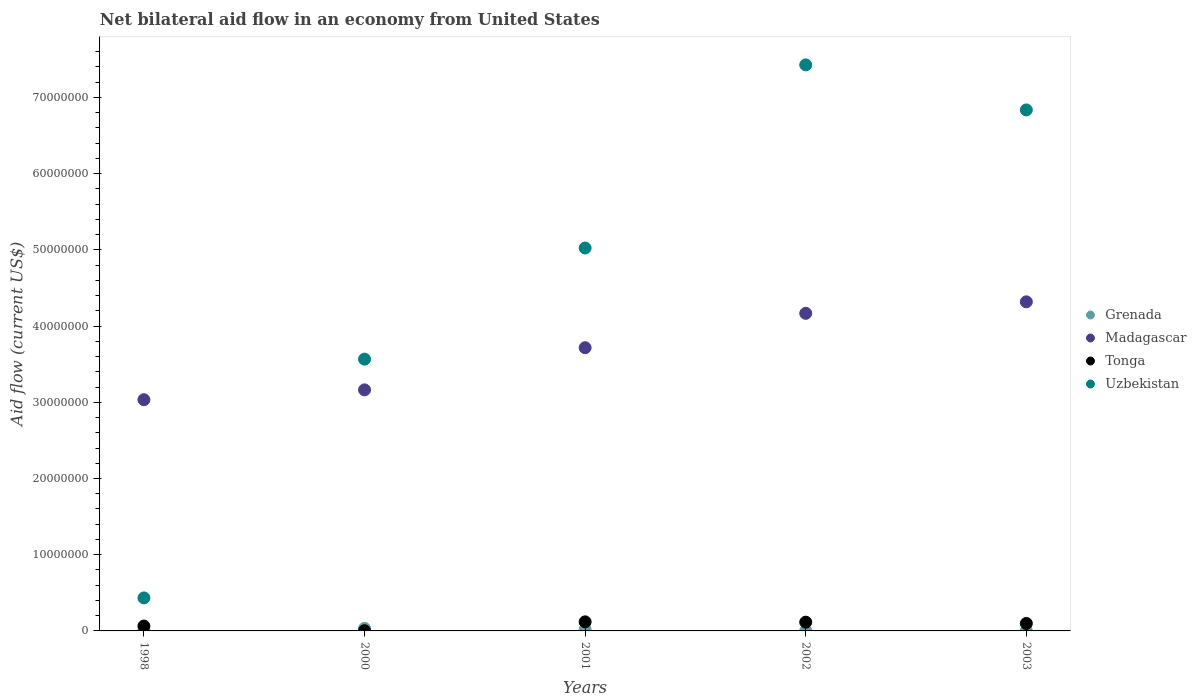How many different coloured dotlines are there?
Provide a succinct answer. 4. What is the net bilateral aid flow in Tonga in 2002?
Offer a very short reply. 1.15e+06. Across all years, what is the maximum net bilateral aid flow in Uzbekistan?
Make the answer very short. 7.43e+07. Across all years, what is the minimum net bilateral aid flow in Uzbekistan?
Your answer should be very brief. 4.33e+06. In which year was the net bilateral aid flow in Uzbekistan minimum?
Your response must be concise. 1998. What is the total net bilateral aid flow in Madagascar in the graph?
Ensure brevity in your answer.  1.84e+08. What is the difference between the net bilateral aid flow in Tonga in 2001 and that in 2002?
Ensure brevity in your answer.  4.00e+04. What is the difference between the net bilateral aid flow in Uzbekistan in 2002 and the net bilateral aid flow in Madagascar in 2001?
Give a very brief answer. 3.71e+07. What is the average net bilateral aid flow in Madagascar per year?
Your response must be concise. 3.68e+07. In the year 1998, what is the difference between the net bilateral aid flow in Tonga and net bilateral aid flow in Madagascar?
Provide a short and direct response. -2.97e+07. In how many years, is the net bilateral aid flow in Uzbekistan greater than 42000000 US$?
Offer a terse response. 3. What is the ratio of the net bilateral aid flow in Tonga in 1998 to that in 2002?
Give a very brief answer. 0.56. Is the net bilateral aid flow in Tonga in 2000 less than that in 2003?
Your answer should be very brief. Yes. Is the difference between the net bilateral aid flow in Tonga in 2002 and 2003 greater than the difference between the net bilateral aid flow in Madagascar in 2002 and 2003?
Offer a terse response. Yes. What is the difference between the highest and the second highest net bilateral aid flow in Madagascar?
Provide a succinct answer. 1.51e+06. What is the difference between the highest and the lowest net bilateral aid flow in Madagascar?
Offer a terse response. 1.28e+07. Is the sum of the net bilateral aid flow in Uzbekistan in 2001 and 2003 greater than the maximum net bilateral aid flow in Tonga across all years?
Give a very brief answer. Yes. Is it the case that in every year, the sum of the net bilateral aid flow in Tonga and net bilateral aid flow in Grenada  is greater than the sum of net bilateral aid flow in Uzbekistan and net bilateral aid flow in Madagascar?
Make the answer very short. No. Does the net bilateral aid flow in Uzbekistan monotonically increase over the years?
Your response must be concise. No. Is the net bilateral aid flow in Grenada strictly less than the net bilateral aid flow in Madagascar over the years?
Keep it short and to the point. Yes. What is the difference between two consecutive major ticks on the Y-axis?
Ensure brevity in your answer.  1.00e+07. Are the values on the major ticks of Y-axis written in scientific E-notation?
Make the answer very short. No. Does the graph contain any zero values?
Provide a short and direct response. No. Does the graph contain grids?
Provide a succinct answer. No. How many legend labels are there?
Offer a very short reply. 4. What is the title of the graph?
Your answer should be very brief. Net bilateral aid flow in an economy from United States. What is the Aid flow (current US$) in Madagascar in 1998?
Make the answer very short. 3.03e+07. What is the Aid flow (current US$) of Tonga in 1998?
Make the answer very short. 6.40e+05. What is the Aid flow (current US$) in Uzbekistan in 1998?
Provide a succinct answer. 4.33e+06. What is the Aid flow (current US$) in Madagascar in 2000?
Offer a terse response. 3.16e+07. What is the Aid flow (current US$) of Tonga in 2000?
Make the answer very short. 3.00e+04. What is the Aid flow (current US$) in Uzbekistan in 2000?
Ensure brevity in your answer.  3.57e+07. What is the Aid flow (current US$) in Madagascar in 2001?
Provide a short and direct response. 3.72e+07. What is the Aid flow (current US$) in Tonga in 2001?
Make the answer very short. 1.19e+06. What is the Aid flow (current US$) in Uzbekistan in 2001?
Offer a very short reply. 5.02e+07. What is the Aid flow (current US$) of Grenada in 2002?
Provide a succinct answer. 2.00e+04. What is the Aid flow (current US$) of Madagascar in 2002?
Make the answer very short. 4.17e+07. What is the Aid flow (current US$) in Tonga in 2002?
Offer a very short reply. 1.15e+06. What is the Aid flow (current US$) of Uzbekistan in 2002?
Make the answer very short. 7.43e+07. What is the Aid flow (current US$) in Madagascar in 2003?
Provide a succinct answer. 4.32e+07. What is the Aid flow (current US$) of Tonga in 2003?
Ensure brevity in your answer.  9.80e+05. What is the Aid flow (current US$) of Uzbekistan in 2003?
Your answer should be very brief. 6.84e+07. Across all years, what is the maximum Aid flow (current US$) of Grenada?
Provide a succinct answer. 3.40e+05. Across all years, what is the maximum Aid flow (current US$) of Madagascar?
Provide a short and direct response. 4.32e+07. Across all years, what is the maximum Aid flow (current US$) in Tonga?
Ensure brevity in your answer.  1.19e+06. Across all years, what is the maximum Aid flow (current US$) of Uzbekistan?
Provide a succinct answer. 7.43e+07. Across all years, what is the minimum Aid flow (current US$) of Grenada?
Offer a terse response. 10000. Across all years, what is the minimum Aid flow (current US$) of Madagascar?
Keep it short and to the point. 3.03e+07. Across all years, what is the minimum Aid flow (current US$) of Tonga?
Your answer should be very brief. 3.00e+04. Across all years, what is the minimum Aid flow (current US$) of Uzbekistan?
Provide a short and direct response. 4.33e+06. What is the total Aid flow (current US$) of Madagascar in the graph?
Your answer should be compact. 1.84e+08. What is the total Aid flow (current US$) in Tonga in the graph?
Give a very brief answer. 3.99e+06. What is the total Aid flow (current US$) of Uzbekistan in the graph?
Your answer should be compact. 2.33e+08. What is the difference between the Aid flow (current US$) of Madagascar in 1998 and that in 2000?
Offer a very short reply. -1.29e+06. What is the difference between the Aid flow (current US$) of Uzbekistan in 1998 and that in 2000?
Ensure brevity in your answer.  -3.13e+07. What is the difference between the Aid flow (current US$) of Grenada in 1998 and that in 2001?
Your answer should be very brief. -5.00e+04. What is the difference between the Aid flow (current US$) of Madagascar in 1998 and that in 2001?
Provide a short and direct response. -6.82e+06. What is the difference between the Aid flow (current US$) of Tonga in 1998 and that in 2001?
Make the answer very short. -5.50e+05. What is the difference between the Aid flow (current US$) of Uzbekistan in 1998 and that in 2001?
Offer a very short reply. -4.59e+07. What is the difference between the Aid flow (current US$) of Madagascar in 1998 and that in 2002?
Your response must be concise. -1.13e+07. What is the difference between the Aid flow (current US$) of Tonga in 1998 and that in 2002?
Ensure brevity in your answer.  -5.10e+05. What is the difference between the Aid flow (current US$) of Uzbekistan in 1998 and that in 2002?
Offer a very short reply. -6.99e+07. What is the difference between the Aid flow (current US$) of Madagascar in 1998 and that in 2003?
Offer a terse response. -1.28e+07. What is the difference between the Aid flow (current US$) of Uzbekistan in 1998 and that in 2003?
Your response must be concise. -6.40e+07. What is the difference between the Aid flow (current US$) of Madagascar in 2000 and that in 2001?
Give a very brief answer. -5.53e+06. What is the difference between the Aid flow (current US$) of Tonga in 2000 and that in 2001?
Ensure brevity in your answer.  -1.16e+06. What is the difference between the Aid flow (current US$) of Uzbekistan in 2000 and that in 2001?
Make the answer very short. -1.46e+07. What is the difference between the Aid flow (current US$) of Grenada in 2000 and that in 2002?
Your response must be concise. 3.20e+05. What is the difference between the Aid flow (current US$) of Madagascar in 2000 and that in 2002?
Keep it short and to the point. -1.00e+07. What is the difference between the Aid flow (current US$) in Tonga in 2000 and that in 2002?
Make the answer very short. -1.12e+06. What is the difference between the Aid flow (current US$) of Uzbekistan in 2000 and that in 2002?
Ensure brevity in your answer.  -3.86e+07. What is the difference between the Aid flow (current US$) of Madagascar in 2000 and that in 2003?
Offer a terse response. -1.16e+07. What is the difference between the Aid flow (current US$) in Tonga in 2000 and that in 2003?
Your answer should be very brief. -9.50e+05. What is the difference between the Aid flow (current US$) of Uzbekistan in 2000 and that in 2003?
Offer a terse response. -3.27e+07. What is the difference between the Aid flow (current US$) in Grenada in 2001 and that in 2002?
Provide a short and direct response. 1.70e+05. What is the difference between the Aid flow (current US$) in Madagascar in 2001 and that in 2002?
Give a very brief answer. -4.51e+06. What is the difference between the Aid flow (current US$) in Uzbekistan in 2001 and that in 2002?
Your answer should be compact. -2.40e+07. What is the difference between the Aid flow (current US$) of Madagascar in 2001 and that in 2003?
Provide a short and direct response. -6.02e+06. What is the difference between the Aid flow (current US$) in Uzbekistan in 2001 and that in 2003?
Your answer should be compact. -1.81e+07. What is the difference between the Aid flow (current US$) in Madagascar in 2002 and that in 2003?
Make the answer very short. -1.51e+06. What is the difference between the Aid flow (current US$) in Tonga in 2002 and that in 2003?
Your answer should be very brief. 1.70e+05. What is the difference between the Aid flow (current US$) of Uzbekistan in 2002 and that in 2003?
Your answer should be compact. 5.91e+06. What is the difference between the Aid flow (current US$) in Grenada in 1998 and the Aid flow (current US$) in Madagascar in 2000?
Your answer should be compact. -3.15e+07. What is the difference between the Aid flow (current US$) in Grenada in 1998 and the Aid flow (current US$) in Uzbekistan in 2000?
Provide a succinct answer. -3.55e+07. What is the difference between the Aid flow (current US$) in Madagascar in 1998 and the Aid flow (current US$) in Tonga in 2000?
Your response must be concise. 3.03e+07. What is the difference between the Aid flow (current US$) in Madagascar in 1998 and the Aid flow (current US$) in Uzbekistan in 2000?
Provide a short and direct response. -5.32e+06. What is the difference between the Aid flow (current US$) of Tonga in 1998 and the Aid flow (current US$) of Uzbekistan in 2000?
Your answer should be very brief. -3.50e+07. What is the difference between the Aid flow (current US$) in Grenada in 1998 and the Aid flow (current US$) in Madagascar in 2001?
Your answer should be compact. -3.70e+07. What is the difference between the Aid flow (current US$) in Grenada in 1998 and the Aid flow (current US$) in Tonga in 2001?
Your answer should be compact. -1.05e+06. What is the difference between the Aid flow (current US$) in Grenada in 1998 and the Aid flow (current US$) in Uzbekistan in 2001?
Offer a terse response. -5.01e+07. What is the difference between the Aid flow (current US$) in Madagascar in 1998 and the Aid flow (current US$) in Tonga in 2001?
Offer a very short reply. 2.92e+07. What is the difference between the Aid flow (current US$) of Madagascar in 1998 and the Aid flow (current US$) of Uzbekistan in 2001?
Your response must be concise. -1.99e+07. What is the difference between the Aid flow (current US$) in Tonga in 1998 and the Aid flow (current US$) in Uzbekistan in 2001?
Your answer should be very brief. -4.96e+07. What is the difference between the Aid flow (current US$) of Grenada in 1998 and the Aid flow (current US$) of Madagascar in 2002?
Your answer should be compact. -4.15e+07. What is the difference between the Aid flow (current US$) of Grenada in 1998 and the Aid flow (current US$) of Tonga in 2002?
Ensure brevity in your answer.  -1.01e+06. What is the difference between the Aid flow (current US$) of Grenada in 1998 and the Aid flow (current US$) of Uzbekistan in 2002?
Ensure brevity in your answer.  -7.41e+07. What is the difference between the Aid flow (current US$) of Madagascar in 1998 and the Aid flow (current US$) of Tonga in 2002?
Your answer should be compact. 2.92e+07. What is the difference between the Aid flow (current US$) of Madagascar in 1998 and the Aid flow (current US$) of Uzbekistan in 2002?
Make the answer very short. -4.39e+07. What is the difference between the Aid flow (current US$) of Tonga in 1998 and the Aid flow (current US$) of Uzbekistan in 2002?
Give a very brief answer. -7.36e+07. What is the difference between the Aid flow (current US$) in Grenada in 1998 and the Aid flow (current US$) in Madagascar in 2003?
Your answer should be very brief. -4.30e+07. What is the difference between the Aid flow (current US$) in Grenada in 1998 and the Aid flow (current US$) in Tonga in 2003?
Provide a short and direct response. -8.40e+05. What is the difference between the Aid flow (current US$) in Grenada in 1998 and the Aid flow (current US$) in Uzbekistan in 2003?
Provide a short and direct response. -6.82e+07. What is the difference between the Aid flow (current US$) of Madagascar in 1998 and the Aid flow (current US$) of Tonga in 2003?
Keep it short and to the point. 2.94e+07. What is the difference between the Aid flow (current US$) of Madagascar in 1998 and the Aid flow (current US$) of Uzbekistan in 2003?
Your answer should be compact. -3.80e+07. What is the difference between the Aid flow (current US$) in Tonga in 1998 and the Aid flow (current US$) in Uzbekistan in 2003?
Ensure brevity in your answer.  -6.77e+07. What is the difference between the Aid flow (current US$) of Grenada in 2000 and the Aid flow (current US$) of Madagascar in 2001?
Provide a succinct answer. -3.68e+07. What is the difference between the Aid flow (current US$) of Grenada in 2000 and the Aid flow (current US$) of Tonga in 2001?
Provide a short and direct response. -8.50e+05. What is the difference between the Aid flow (current US$) in Grenada in 2000 and the Aid flow (current US$) in Uzbekistan in 2001?
Your answer should be compact. -4.99e+07. What is the difference between the Aid flow (current US$) in Madagascar in 2000 and the Aid flow (current US$) in Tonga in 2001?
Give a very brief answer. 3.04e+07. What is the difference between the Aid flow (current US$) in Madagascar in 2000 and the Aid flow (current US$) in Uzbekistan in 2001?
Provide a short and direct response. -1.86e+07. What is the difference between the Aid flow (current US$) of Tonga in 2000 and the Aid flow (current US$) of Uzbekistan in 2001?
Provide a succinct answer. -5.02e+07. What is the difference between the Aid flow (current US$) of Grenada in 2000 and the Aid flow (current US$) of Madagascar in 2002?
Make the answer very short. -4.13e+07. What is the difference between the Aid flow (current US$) of Grenada in 2000 and the Aid flow (current US$) of Tonga in 2002?
Offer a terse response. -8.10e+05. What is the difference between the Aid flow (current US$) of Grenada in 2000 and the Aid flow (current US$) of Uzbekistan in 2002?
Offer a very short reply. -7.39e+07. What is the difference between the Aid flow (current US$) in Madagascar in 2000 and the Aid flow (current US$) in Tonga in 2002?
Make the answer very short. 3.05e+07. What is the difference between the Aid flow (current US$) in Madagascar in 2000 and the Aid flow (current US$) in Uzbekistan in 2002?
Your answer should be compact. -4.26e+07. What is the difference between the Aid flow (current US$) of Tonga in 2000 and the Aid flow (current US$) of Uzbekistan in 2002?
Ensure brevity in your answer.  -7.42e+07. What is the difference between the Aid flow (current US$) of Grenada in 2000 and the Aid flow (current US$) of Madagascar in 2003?
Offer a terse response. -4.28e+07. What is the difference between the Aid flow (current US$) in Grenada in 2000 and the Aid flow (current US$) in Tonga in 2003?
Keep it short and to the point. -6.40e+05. What is the difference between the Aid flow (current US$) in Grenada in 2000 and the Aid flow (current US$) in Uzbekistan in 2003?
Give a very brief answer. -6.80e+07. What is the difference between the Aid flow (current US$) in Madagascar in 2000 and the Aid flow (current US$) in Tonga in 2003?
Provide a short and direct response. 3.06e+07. What is the difference between the Aid flow (current US$) in Madagascar in 2000 and the Aid flow (current US$) in Uzbekistan in 2003?
Your answer should be very brief. -3.67e+07. What is the difference between the Aid flow (current US$) of Tonga in 2000 and the Aid flow (current US$) of Uzbekistan in 2003?
Keep it short and to the point. -6.83e+07. What is the difference between the Aid flow (current US$) in Grenada in 2001 and the Aid flow (current US$) in Madagascar in 2002?
Offer a very short reply. -4.15e+07. What is the difference between the Aid flow (current US$) of Grenada in 2001 and the Aid flow (current US$) of Tonga in 2002?
Your answer should be compact. -9.60e+05. What is the difference between the Aid flow (current US$) of Grenada in 2001 and the Aid flow (current US$) of Uzbekistan in 2002?
Provide a succinct answer. -7.41e+07. What is the difference between the Aid flow (current US$) of Madagascar in 2001 and the Aid flow (current US$) of Tonga in 2002?
Make the answer very short. 3.60e+07. What is the difference between the Aid flow (current US$) of Madagascar in 2001 and the Aid flow (current US$) of Uzbekistan in 2002?
Provide a short and direct response. -3.71e+07. What is the difference between the Aid flow (current US$) of Tonga in 2001 and the Aid flow (current US$) of Uzbekistan in 2002?
Offer a terse response. -7.31e+07. What is the difference between the Aid flow (current US$) of Grenada in 2001 and the Aid flow (current US$) of Madagascar in 2003?
Your answer should be compact. -4.30e+07. What is the difference between the Aid flow (current US$) in Grenada in 2001 and the Aid flow (current US$) in Tonga in 2003?
Provide a succinct answer. -7.90e+05. What is the difference between the Aid flow (current US$) in Grenada in 2001 and the Aid flow (current US$) in Uzbekistan in 2003?
Make the answer very short. -6.82e+07. What is the difference between the Aid flow (current US$) in Madagascar in 2001 and the Aid flow (current US$) in Tonga in 2003?
Keep it short and to the point. 3.62e+07. What is the difference between the Aid flow (current US$) of Madagascar in 2001 and the Aid flow (current US$) of Uzbekistan in 2003?
Keep it short and to the point. -3.12e+07. What is the difference between the Aid flow (current US$) in Tonga in 2001 and the Aid flow (current US$) in Uzbekistan in 2003?
Offer a terse response. -6.72e+07. What is the difference between the Aid flow (current US$) in Grenada in 2002 and the Aid flow (current US$) in Madagascar in 2003?
Provide a short and direct response. -4.32e+07. What is the difference between the Aid flow (current US$) in Grenada in 2002 and the Aid flow (current US$) in Tonga in 2003?
Your answer should be very brief. -9.60e+05. What is the difference between the Aid flow (current US$) in Grenada in 2002 and the Aid flow (current US$) in Uzbekistan in 2003?
Offer a terse response. -6.83e+07. What is the difference between the Aid flow (current US$) in Madagascar in 2002 and the Aid flow (current US$) in Tonga in 2003?
Offer a terse response. 4.07e+07. What is the difference between the Aid flow (current US$) of Madagascar in 2002 and the Aid flow (current US$) of Uzbekistan in 2003?
Your response must be concise. -2.67e+07. What is the difference between the Aid flow (current US$) in Tonga in 2002 and the Aid flow (current US$) in Uzbekistan in 2003?
Provide a succinct answer. -6.72e+07. What is the average Aid flow (current US$) in Grenada per year?
Keep it short and to the point. 1.40e+05. What is the average Aid flow (current US$) in Madagascar per year?
Ensure brevity in your answer.  3.68e+07. What is the average Aid flow (current US$) in Tonga per year?
Your answer should be compact. 7.98e+05. What is the average Aid flow (current US$) of Uzbekistan per year?
Provide a succinct answer. 4.66e+07. In the year 1998, what is the difference between the Aid flow (current US$) of Grenada and Aid flow (current US$) of Madagascar?
Your answer should be compact. -3.02e+07. In the year 1998, what is the difference between the Aid flow (current US$) of Grenada and Aid flow (current US$) of Tonga?
Keep it short and to the point. -5.00e+05. In the year 1998, what is the difference between the Aid flow (current US$) in Grenada and Aid flow (current US$) in Uzbekistan?
Your response must be concise. -4.19e+06. In the year 1998, what is the difference between the Aid flow (current US$) in Madagascar and Aid flow (current US$) in Tonga?
Keep it short and to the point. 2.97e+07. In the year 1998, what is the difference between the Aid flow (current US$) in Madagascar and Aid flow (current US$) in Uzbekistan?
Offer a terse response. 2.60e+07. In the year 1998, what is the difference between the Aid flow (current US$) of Tonga and Aid flow (current US$) of Uzbekistan?
Ensure brevity in your answer.  -3.69e+06. In the year 2000, what is the difference between the Aid flow (current US$) in Grenada and Aid flow (current US$) in Madagascar?
Make the answer very short. -3.13e+07. In the year 2000, what is the difference between the Aid flow (current US$) of Grenada and Aid flow (current US$) of Uzbekistan?
Your response must be concise. -3.53e+07. In the year 2000, what is the difference between the Aid flow (current US$) of Madagascar and Aid flow (current US$) of Tonga?
Provide a short and direct response. 3.16e+07. In the year 2000, what is the difference between the Aid flow (current US$) in Madagascar and Aid flow (current US$) in Uzbekistan?
Offer a very short reply. -4.03e+06. In the year 2000, what is the difference between the Aid flow (current US$) in Tonga and Aid flow (current US$) in Uzbekistan?
Your response must be concise. -3.56e+07. In the year 2001, what is the difference between the Aid flow (current US$) in Grenada and Aid flow (current US$) in Madagascar?
Your answer should be very brief. -3.70e+07. In the year 2001, what is the difference between the Aid flow (current US$) in Grenada and Aid flow (current US$) in Tonga?
Keep it short and to the point. -1.00e+06. In the year 2001, what is the difference between the Aid flow (current US$) in Grenada and Aid flow (current US$) in Uzbekistan?
Your response must be concise. -5.00e+07. In the year 2001, what is the difference between the Aid flow (current US$) of Madagascar and Aid flow (current US$) of Tonga?
Provide a succinct answer. 3.60e+07. In the year 2001, what is the difference between the Aid flow (current US$) of Madagascar and Aid flow (current US$) of Uzbekistan?
Provide a succinct answer. -1.31e+07. In the year 2001, what is the difference between the Aid flow (current US$) of Tonga and Aid flow (current US$) of Uzbekistan?
Keep it short and to the point. -4.90e+07. In the year 2002, what is the difference between the Aid flow (current US$) in Grenada and Aid flow (current US$) in Madagascar?
Your response must be concise. -4.16e+07. In the year 2002, what is the difference between the Aid flow (current US$) in Grenada and Aid flow (current US$) in Tonga?
Make the answer very short. -1.13e+06. In the year 2002, what is the difference between the Aid flow (current US$) of Grenada and Aid flow (current US$) of Uzbekistan?
Keep it short and to the point. -7.42e+07. In the year 2002, what is the difference between the Aid flow (current US$) in Madagascar and Aid flow (current US$) in Tonga?
Your answer should be very brief. 4.05e+07. In the year 2002, what is the difference between the Aid flow (current US$) in Madagascar and Aid flow (current US$) in Uzbekistan?
Provide a succinct answer. -3.26e+07. In the year 2002, what is the difference between the Aid flow (current US$) of Tonga and Aid flow (current US$) of Uzbekistan?
Give a very brief answer. -7.31e+07. In the year 2003, what is the difference between the Aid flow (current US$) of Grenada and Aid flow (current US$) of Madagascar?
Provide a short and direct response. -4.32e+07. In the year 2003, what is the difference between the Aid flow (current US$) of Grenada and Aid flow (current US$) of Tonga?
Your response must be concise. -9.70e+05. In the year 2003, what is the difference between the Aid flow (current US$) of Grenada and Aid flow (current US$) of Uzbekistan?
Give a very brief answer. -6.84e+07. In the year 2003, what is the difference between the Aid flow (current US$) of Madagascar and Aid flow (current US$) of Tonga?
Your answer should be compact. 4.22e+07. In the year 2003, what is the difference between the Aid flow (current US$) of Madagascar and Aid flow (current US$) of Uzbekistan?
Your answer should be very brief. -2.52e+07. In the year 2003, what is the difference between the Aid flow (current US$) in Tonga and Aid flow (current US$) in Uzbekistan?
Give a very brief answer. -6.74e+07. What is the ratio of the Aid flow (current US$) of Grenada in 1998 to that in 2000?
Keep it short and to the point. 0.41. What is the ratio of the Aid flow (current US$) of Madagascar in 1998 to that in 2000?
Your answer should be compact. 0.96. What is the ratio of the Aid flow (current US$) in Tonga in 1998 to that in 2000?
Offer a terse response. 21.33. What is the ratio of the Aid flow (current US$) in Uzbekistan in 1998 to that in 2000?
Provide a succinct answer. 0.12. What is the ratio of the Aid flow (current US$) in Grenada in 1998 to that in 2001?
Your response must be concise. 0.74. What is the ratio of the Aid flow (current US$) in Madagascar in 1998 to that in 2001?
Your answer should be compact. 0.82. What is the ratio of the Aid flow (current US$) of Tonga in 1998 to that in 2001?
Offer a terse response. 0.54. What is the ratio of the Aid flow (current US$) in Uzbekistan in 1998 to that in 2001?
Ensure brevity in your answer.  0.09. What is the ratio of the Aid flow (current US$) of Madagascar in 1998 to that in 2002?
Offer a terse response. 0.73. What is the ratio of the Aid flow (current US$) of Tonga in 1998 to that in 2002?
Your answer should be very brief. 0.56. What is the ratio of the Aid flow (current US$) in Uzbekistan in 1998 to that in 2002?
Offer a terse response. 0.06. What is the ratio of the Aid flow (current US$) in Grenada in 1998 to that in 2003?
Your response must be concise. 14. What is the ratio of the Aid flow (current US$) of Madagascar in 1998 to that in 2003?
Ensure brevity in your answer.  0.7. What is the ratio of the Aid flow (current US$) in Tonga in 1998 to that in 2003?
Your answer should be compact. 0.65. What is the ratio of the Aid flow (current US$) in Uzbekistan in 1998 to that in 2003?
Make the answer very short. 0.06. What is the ratio of the Aid flow (current US$) in Grenada in 2000 to that in 2001?
Ensure brevity in your answer.  1.79. What is the ratio of the Aid flow (current US$) of Madagascar in 2000 to that in 2001?
Ensure brevity in your answer.  0.85. What is the ratio of the Aid flow (current US$) in Tonga in 2000 to that in 2001?
Provide a short and direct response. 0.03. What is the ratio of the Aid flow (current US$) of Uzbekistan in 2000 to that in 2001?
Offer a very short reply. 0.71. What is the ratio of the Aid flow (current US$) in Madagascar in 2000 to that in 2002?
Give a very brief answer. 0.76. What is the ratio of the Aid flow (current US$) in Tonga in 2000 to that in 2002?
Provide a succinct answer. 0.03. What is the ratio of the Aid flow (current US$) in Uzbekistan in 2000 to that in 2002?
Offer a very short reply. 0.48. What is the ratio of the Aid flow (current US$) in Grenada in 2000 to that in 2003?
Provide a short and direct response. 34. What is the ratio of the Aid flow (current US$) in Madagascar in 2000 to that in 2003?
Offer a terse response. 0.73. What is the ratio of the Aid flow (current US$) in Tonga in 2000 to that in 2003?
Your answer should be compact. 0.03. What is the ratio of the Aid flow (current US$) of Uzbekistan in 2000 to that in 2003?
Offer a very short reply. 0.52. What is the ratio of the Aid flow (current US$) of Madagascar in 2001 to that in 2002?
Your answer should be compact. 0.89. What is the ratio of the Aid flow (current US$) in Tonga in 2001 to that in 2002?
Provide a succinct answer. 1.03. What is the ratio of the Aid flow (current US$) in Uzbekistan in 2001 to that in 2002?
Provide a succinct answer. 0.68. What is the ratio of the Aid flow (current US$) of Grenada in 2001 to that in 2003?
Offer a very short reply. 19. What is the ratio of the Aid flow (current US$) of Madagascar in 2001 to that in 2003?
Make the answer very short. 0.86. What is the ratio of the Aid flow (current US$) of Tonga in 2001 to that in 2003?
Your answer should be compact. 1.21. What is the ratio of the Aid flow (current US$) of Uzbekistan in 2001 to that in 2003?
Give a very brief answer. 0.73. What is the ratio of the Aid flow (current US$) of Madagascar in 2002 to that in 2003?
Your response must be concise. 0.96. What is the ratio of the Aid flow (current US$) in Tonga in 2002 to that in 2003?
Provide a succinct answer. 1.17. What is the ratio of the Aid flow (current US$) in Uzbekistan in 2002 to that in 2003?
Give a very brief answer. 1.09. What is the difference between the highest and the second highest Aid flow (current US$) of Madagascar?
Your response must be concise. 1.51e+06. What is the difference between the highest and the second highest Aid flow (current US$) in Uzbekistan?
Make the answer very short. 5.91e+06. What is the difference between the highest and the lowest Aid flow (current US$) of Madagascar?
Make the answer very short. 1.28e+07. What is the difference between the highest and the lowest Aid flow (current US$) of Tonga?
Your answer should be compact. 1.16e+06. What is the difference between the highest and the lowest Aid flow (current US$) of Uzbekistan?
Offer a very short reply. 6.99e+07. 